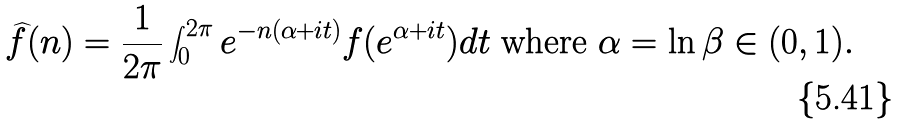Convert formula to latex. <formula><loc_0><loc_0><loc_500><loc_500>\widehat { f } ( n ) = \frac { 1 } { 2 \pi } \int _ { 0 } ^ { 2 \pi } e ^ { - n ( \alpha + i t ) } f ( e ^ { \alpha + i t } ) d t \text { where } \alpha = \ln \beta \in ( 0 , 1 ) .</formula> 